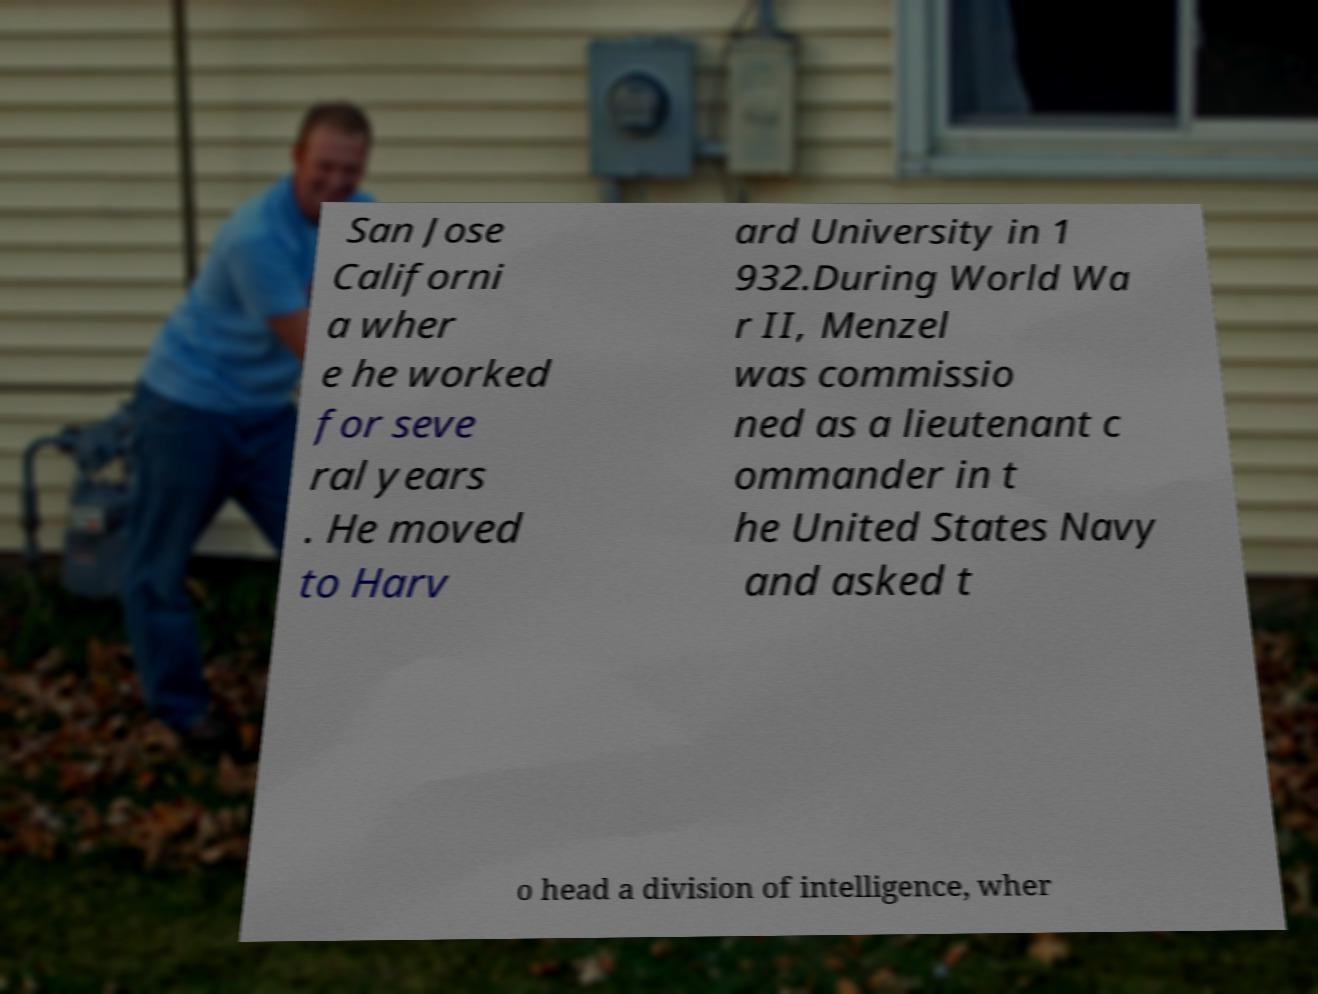For documentation purposes, I need the text within this image transcribed. Could you provide that? San Jose Californi a wher e he worked for seve ral years . He moved to Harv ard University in 1 932.During World Wa r II, Menzel was commissio ned as a lieutenant c ommander in t he United States Navy and asked t o head a division of intelligence, wher 